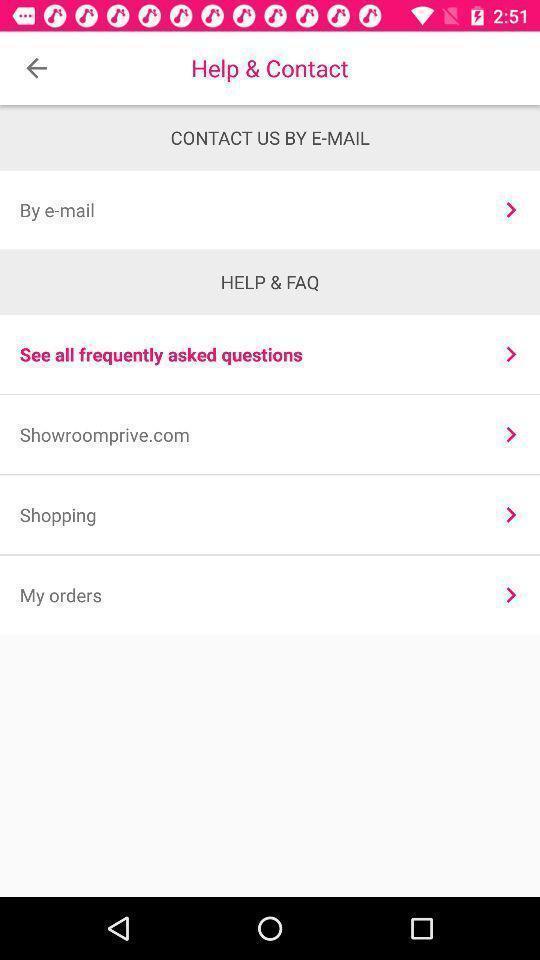Tell me about the visual elements in this screen capture. Page showing support options in app. 